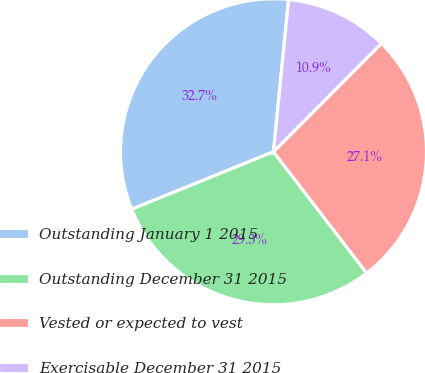Convert chart to OTSL. <chart><loc_0><loc_0><loc_500><loc_500><pie_chart><fcel>Outstanding January 1 2015<fcel>Outstanding December 31 2015<fcel>Vested or expected to vest<fcel>Exercisable December 31 2015<nl><fcel>32.71%<fcel>29.29%<fcel>27.11%<fcel>10.9%<nl></chart> 